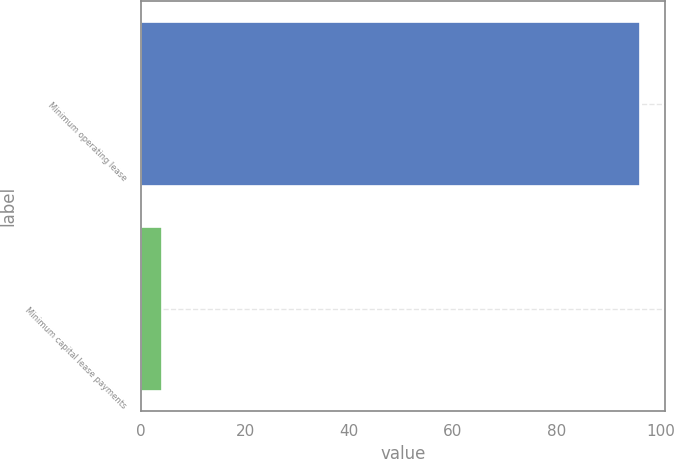<chart> <loc_0><loc_0><loc_500><loc_500><bar_chart><fcel>Minimum operating lease<fcel>Minimum capital lease payments<nl><fcel>96<fcel>4<nl></chart> 